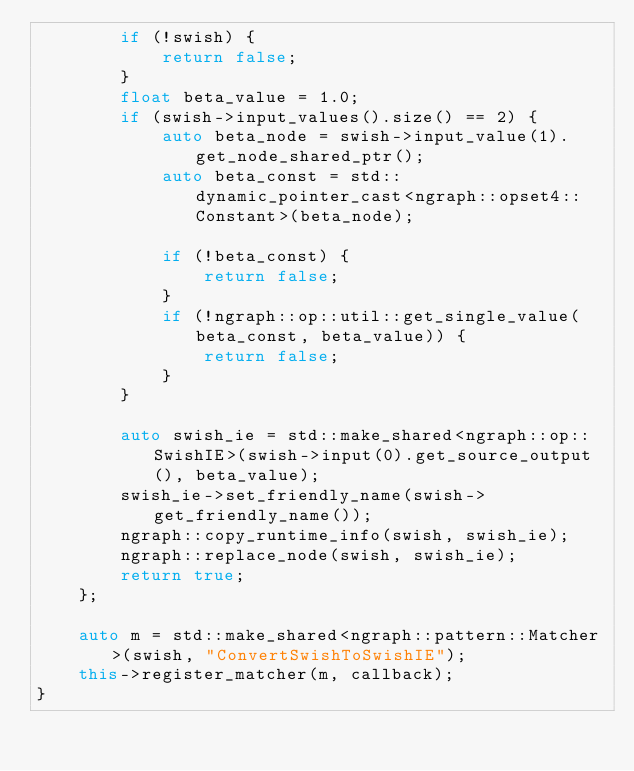Convert code to text. <code><loc_0><loc_0><loc_500><loc_500><_C++_>        if (!swish) {
            return false;
        }
        float beta_value = 1.0;
        if (swish->input_values().size() == 2) {
            auto beta_node = swish->input_value(1).get_node_shared_ptr();
            auto beta_const = std::dynamic_pointer_cast<ngraph::opset4::Constant>(beta_node);

            if (!beta_const) {
                return false;
            }
            if (!ngraph::op::util::get_single_value(beta_const, beta_value)) {
                return false;
            }
        }

        auto swish_ie = std::make_shared<ngraph::op::SwishIE>(swish->input(0).get_source_output(), beta_value);
        swish_ie->set_friendly_name(swish->get_friendly_name());
        ngraph::copy_runtime_info(swish, swish_ie);
        ngraph::replace_node(swish, swish_ie);
        return true;
    };

    auto m = std::make_shared<ngraph::pattern::Matcher>(swish, "ConvertSwishToSwishIE");
    this->register_matcher(m, callback);
}</code> 